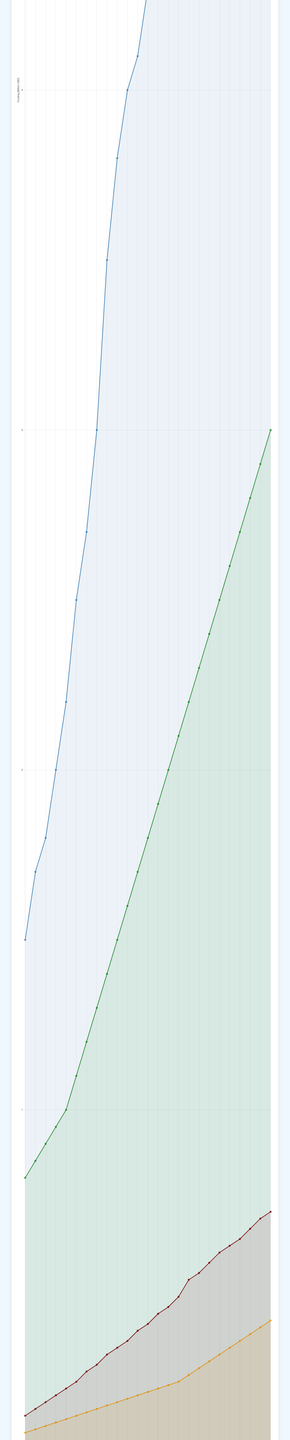How has global funding for chemical engineering research changed from 1998 to 2022? The global funding increased from 1.5 billion USD in 1998 to 7.2 billion USD in 2022. To determine this, refer to the blue line representing global funding and compare the values at the start and end years.
Answer: Increased by 5.7 billion USD Which year saw the steepest increase in global funding? Examine the slope of the blue line on the plot. The steepest increase appears to be around 2005 to 2006, where global funding jumped from 3.0 billion USD to 3.5 billion USD, which is an increase of 0.5 billion USD in one year.
Answer: 2005 to 2006 Compare the funding trends of UP Diliman and other Philippine universities. UP Diliman's funding started at a higher amount (0.1 billion USD in 1998) and increased continuously to 0.7 billion USD in 2022. In contrast, other Philippine universities started at 0.05 billion USD in 1998 and increased to only 0.38 billion USD in 2022. This indicates that UP Diliman consistently received more funding compared to other Philippine universities.
Answer: UP Diliman received more consistent funding increases What is the average yearly increase in local funding for UP Diliman from 1998 to 2022? To find the average yearly increase, calculate the total increase (0.7 billion USD - 0.1 billion USD = 0.6 billion USD) and divide it by the number of years (2022 - 1998 = 24 years). 0.6 / 24 = 0.025 billion USD per year.
Answer: 0.025 billion USD per year Which category had the highest funding in 2022 and how much was it? Look at the end of the lines for the year 2022. The green line representing funding for top global universities is the highest at 3.0 billion USD.
Answer: Top global universities, 3.0 billion USD How much more funding did global institutions receive compared to UP Diliman in 2022? Global funding was 7.2 billion USD, while UP Diliman funding was 0.7 billion USD in 2022. The difference is 7.2 - 0.7 = 6.5 billion USD.
Answer: 6.5 billion USD Which category demonstrated the most consistent growth over the 25 years? Examine the smoothness and linearity of the lines. The orange line representing funding for other Philippine universities shows a consistent and steady increase over the years.
Answer: Other Philippine universities What proportion of total 2022 funding for top global universities and global funding did UP Diliman receive? In 2022, UP Diliman received 0.7 billion USD. The total funding combining top global universities (3.0 billion USD) and global funding (7.2 billion USD) is 10.2 billion USD. The proportion is 0.7 / 10.2 ≈ 0.0686, which is approximately 6.86%.
Answer: Approximately 6.86% During which five-year span did UP Diliman see the highest percentage increase in funding? Calculate the percentage increase for 5-year intervals. The largest percentage increase happened from 2003 to 2008: (0.32 billion USD - 0.2 billion USD) / 0.2 billion USD * 100% = 60%.
Answer: 2003 to 2008 How does the funding trend for UP Diliman compare visually with the other categories? Visually, the maroon line representing UP Diliman is ascending steadily, similar to the other three categories. However, it starts lower and ends lower than global funding and top global universities but higher than other Philippine universities.
Answer: Steadily increasing at a moderate rate 